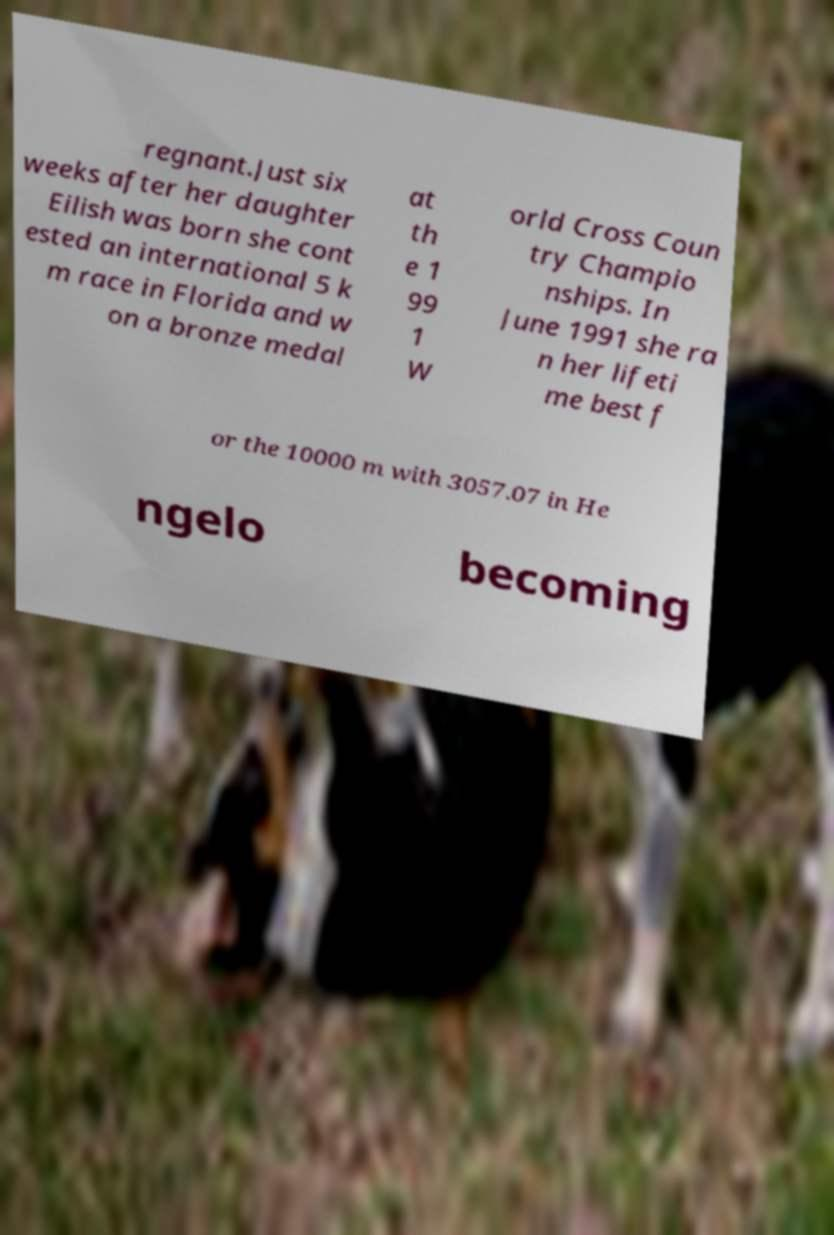Could you assist in decoding the text presented in this image and type it out clearly? regnant.Just six weeks after her daughter Eilish was born she cont ested an international 5 k m race in Florida and w on a bronze medal at th e 1 99 1 W orld Cross Coun try Champio nships. In June 1991 she ra n her lifeti me best f or the 10000 m with 3057.07 in He ngelo becoming 